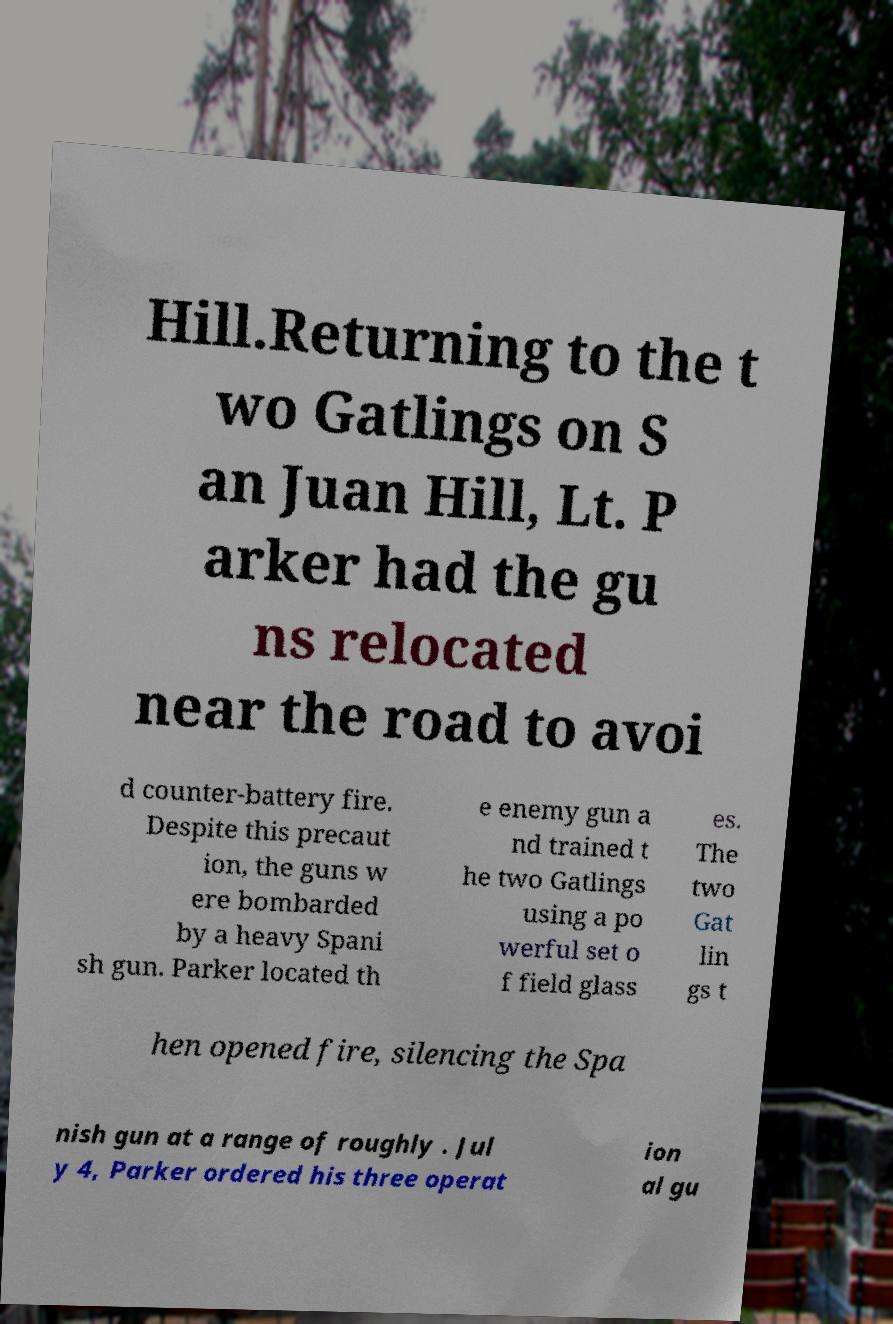I need the written content from this picture converted into text. Can you do that? Hill.Returning to the t wo Gatlings on S an Juan Hill, Lt. P arker had the gu ns relocated near the road to avoi d counter-battery fire. Despite this precaut ion, the guns w ere bombarded by a heavy Spani sh gun. Parker located th e enemy gun a nd trained t he two Gatlings using a po werful set o f field glass es. The two Gat lin gs t hen opened fire, silencing the Spa nish gun at a range of roughly . Jul y 4, Parker ordered his three operat ion al gu 